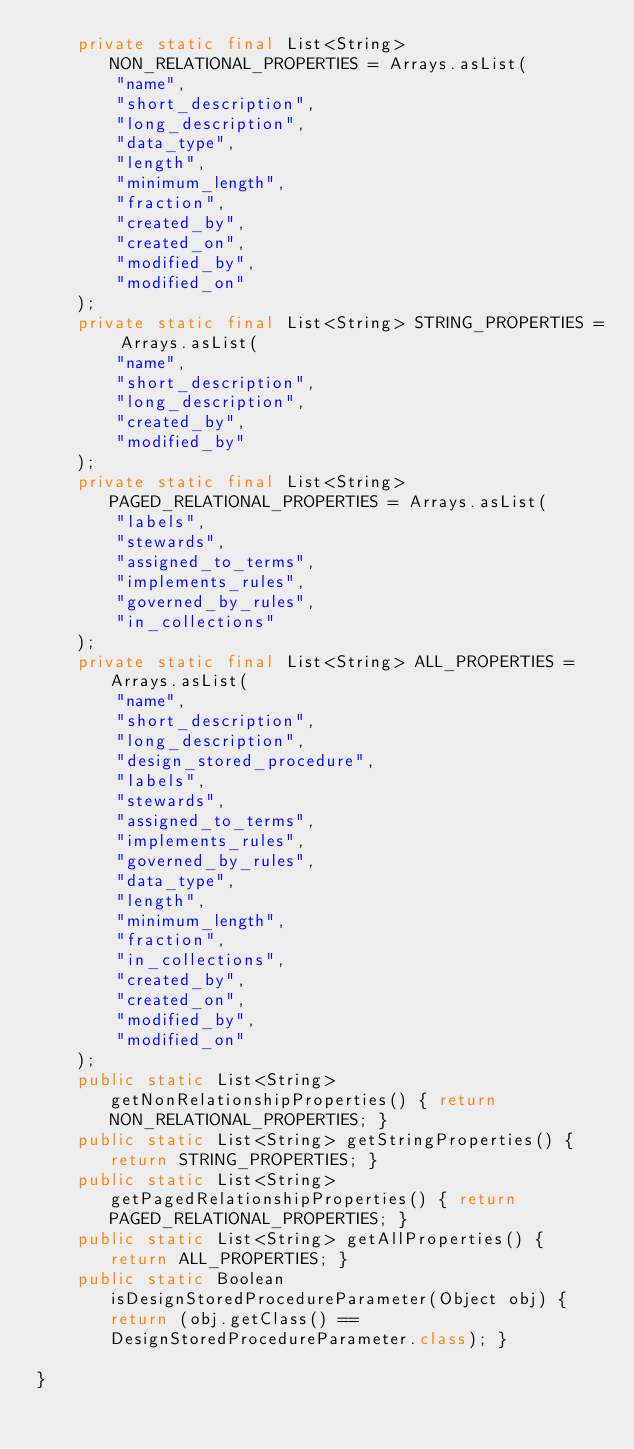Convert code to text. <code><loc_0><loc_0><loc_500><loc_500><_Java_>    private static final List<String> NON_RELATIONAL_PROPERTIES = Arrays.asList(
        "name",
        "short_description",
        "long_description",
        "data_type",
        "length",
        "minimum_length",
        "fraction",
        "created_by",
        "created_on",
        "modified_by",
        "modified_on"
    );
    private static final List<String> STRING_PROPERTIES = Arrays.asList(
        "name",
        "short_description",
        "long_description",
        "created_by",
        "modified_by"
    );
    private static final List<String> PAGED_RELATIONAL_PROPERTIES = Arrays.asList(
        "labels",
        "stewards",
        "assigned_to_terms",
        "implements_rules",
        "governed_by_rules",
        "in_collections"
    );
    private static final List<String> ALL_PROPERTIES = Arrays.asList(
        "name",
        "short_description",
        "long_description",
        "design_stored_procedure",
        "labels",
        "stewards",
        "assigned_to_terms",
        "implements_rules",
        "governed_by_rules",
        "data_type",
        "length",
        "minimum_length",
        "fraction",
        "in_collections",
        "created_by",
        "created_on",
        "modified_by",
        "modified_on"
    );
    public static List<String> getNonRelationshipProperties() { return NON_RELATIONAL_PROPERTIES; }
    public static List<String> getStringProperties() { return STRING_PROPERTIES; }
    public static List<String> getPagedRelationshipProperties() { return PAGED_RELATIONAL_PROPERTIES; }
    public static List<String> getAllProperties() { return ALL_PROPERTIES; }
    public static Boolean isDesignStoredProcedureParameter(Object obj) { return (obj.getClass() == DesignStoredProcedureParameter.class); }

}
</code> 